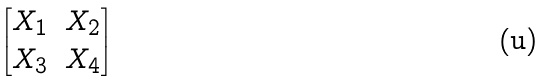<formula> <loc_0><loc_0><loc_500><loc_500>\begin{bmatrix} X _ { 1 } & X _ { 2 } \\ X _ { 3 } & X _ { 4 } \end{bmatrix}</formula> 